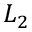Convert formula to latex. <formula><loc_0><loc_0><loc_500><loc_500>L _ { 2 }</formula> 